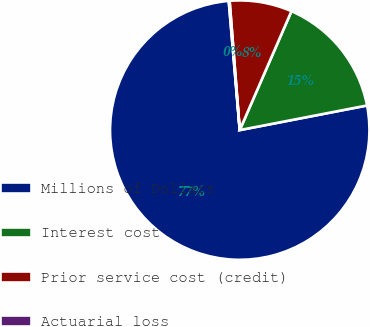Convert chart. <chart><loc_0><loc_0><loc_500><loc_500><pie_chart><fcel>Millions of Dollars<fcel>Interest cost<fcel>Prior service cost (credit)<fcel>Actuarial loss<nl><fcel>76.68%<fcel>15.43%<fcel>7.77%<fcel>0.11%<nl></chart> 